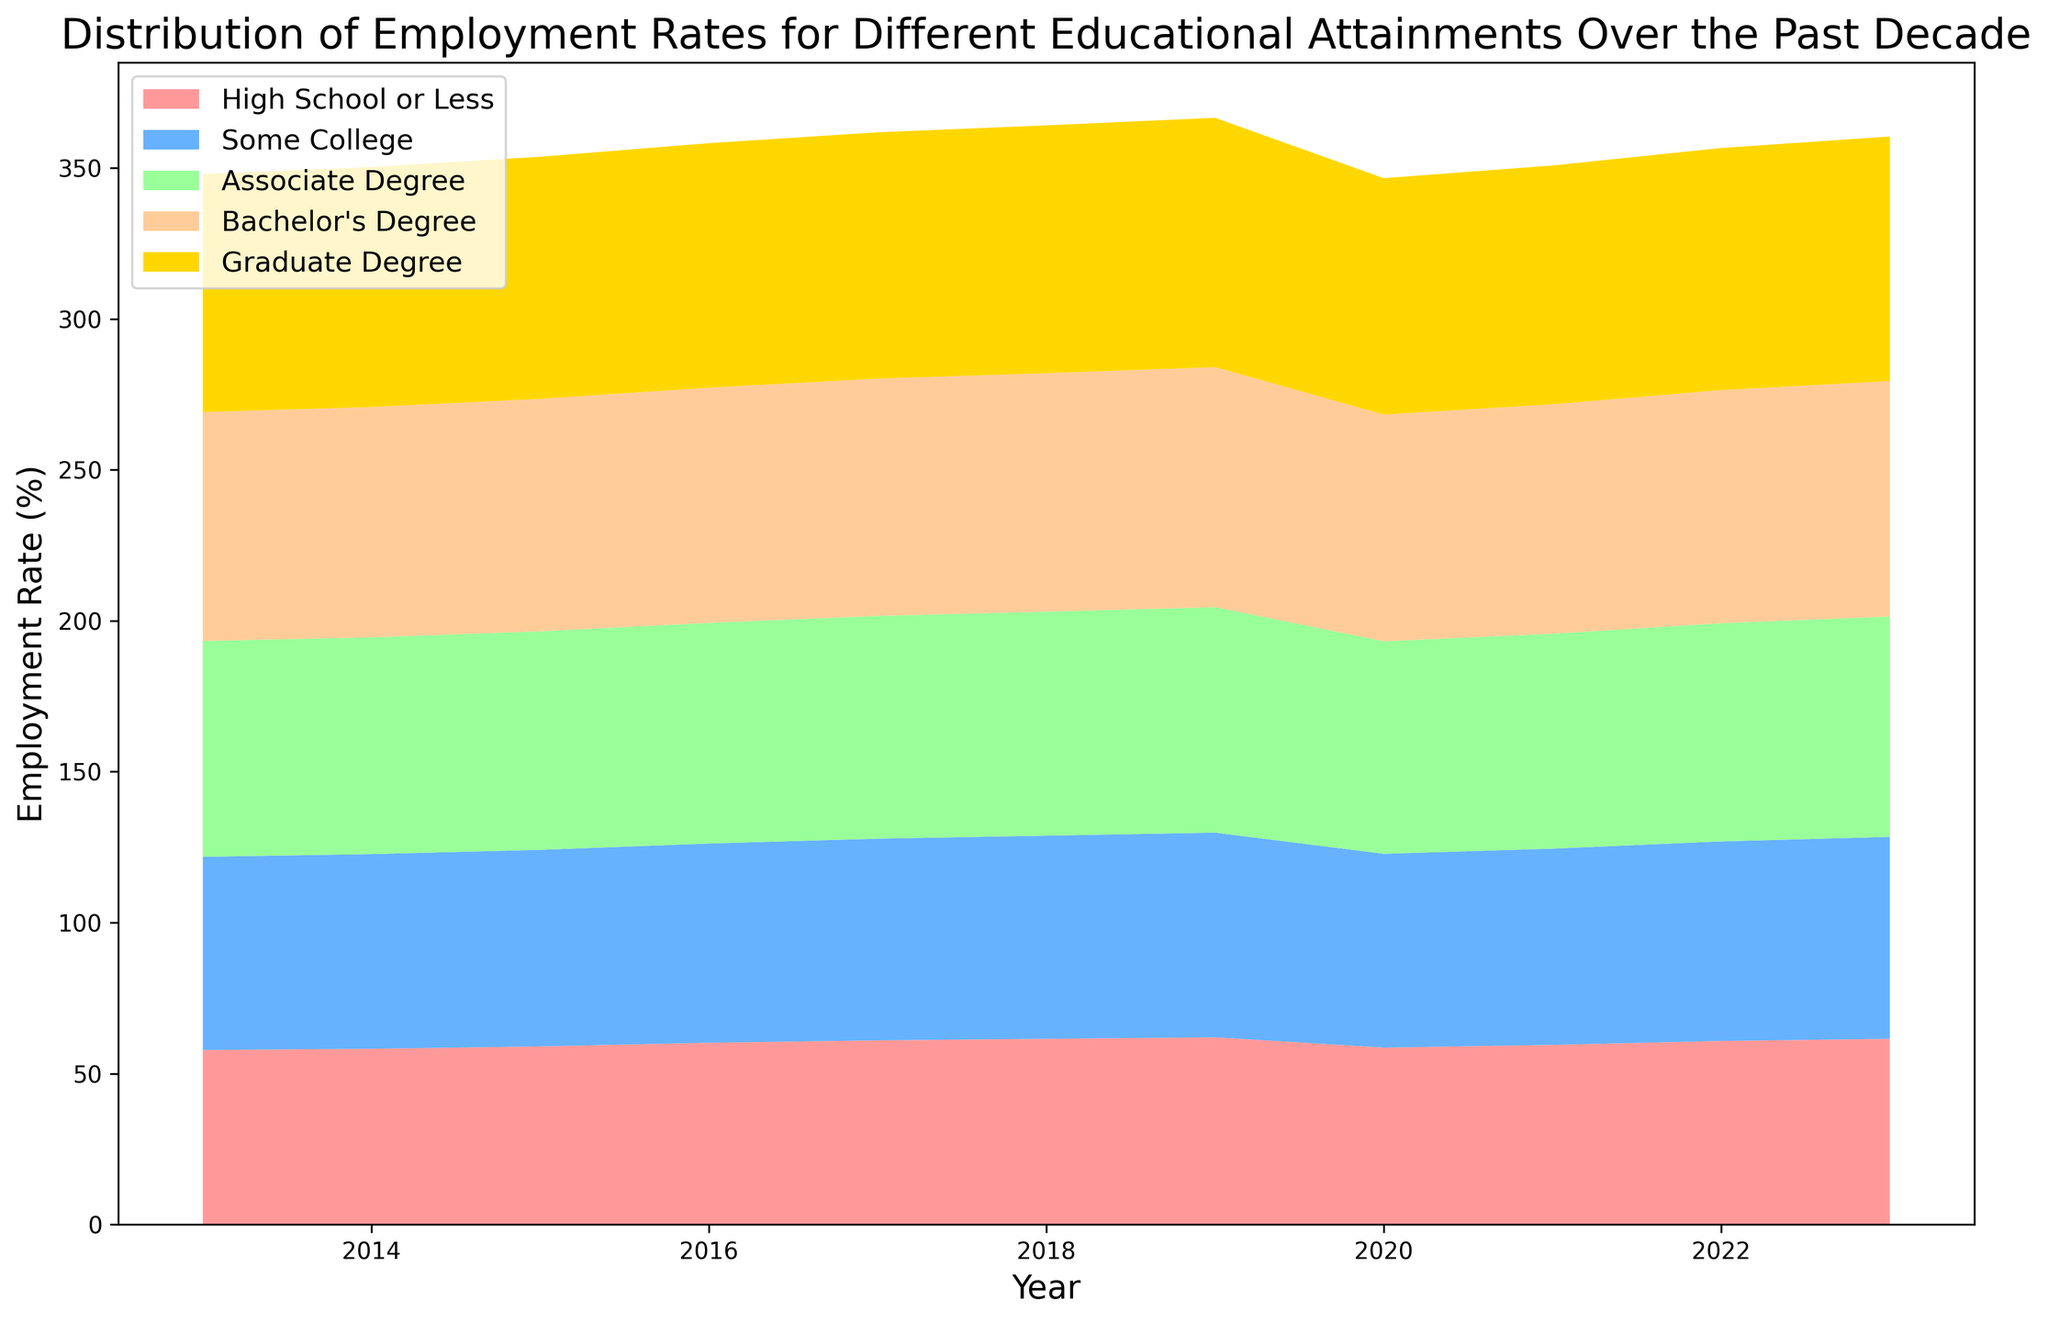What's the trend for employment rates of "Bachelor's Degree" over the past decade? To identify the trend, look at the line for "Bachelor's Degree" and see if it rises, falls, or stays consistent from 2013 to 2023. The employment rate for "Bachelor's Degree" generally increases over the decade, although there is a noticeable drop in 2020.
Answer: Increasing trend with a drop in 2020 In which year did "High School or Less" have the lowest employment rate? To determine this, locate the area representing "High School or Less" and find the lowest point on the vertical axis. The lowest employment rate for "High School or Less" occurred in 2020.
Answer: 2020 How does the employment rate for "Some College" in 2023 compare to that in 2013? Refer to the values for "Some College" in 2023 and 2013. Compare the two figures to determine the difference. The employment rate for "Some College" increased from 64.0% in 2013 to 66.9% in 2023.
Answer: Increased What's the average employment rate for "Graduate Degree" from 2013 to 2023? Calculate the average by summing the employment rates for "Graduate Degree" from each year and dividing by the number of years. Sum: 78.9+79.5+80.2+81+81.6+82.1+82.6+78.3+79.1+80.2+81 = 884.5. There are 11 years, so the average is 884.5/11 ≈ 80.4
Answer: 80.4 Which educational attainment had the smallest increase in employment rate from 2013 to 2023? Compare the increase in employment rates for each educational attainment from 2013 to 2023. Calculate the difference for each category. "High School or Less" increased from 57.8% to 61.5%, an increase of 3.7 percentage points, making it the smallest increase among the groups.
Answer: High School or Less Which year had the highest overall employment rate across all educational attainments? Observe the cumulative height of all areas in the area chart for each year and identify which year appears to have the highest combined employment rates. The combined height is the greatest in 2019.
Answer: 2019 What is the difference in employment rates between "Associate Degree" and "Graduate Degree" in 2023? Find the values for "Associate Degree" and "Graduate Degree" in the year 2023 and subtract one from the other. The employment rates are 73.0% and 81.0%, respectively. The difference is 81.0% - 73.0% = 8.0%.
Answer: 8.0% In which year did "Some College" experience the sharpest decline in employment rate? Review the "Some College" employment rate across all years and identify the year with the largest drop from the previous year. The sharpest decline occurs from 2019 to 2020, where it drops from 67.8% to 64.2%.
Answer: 2020 